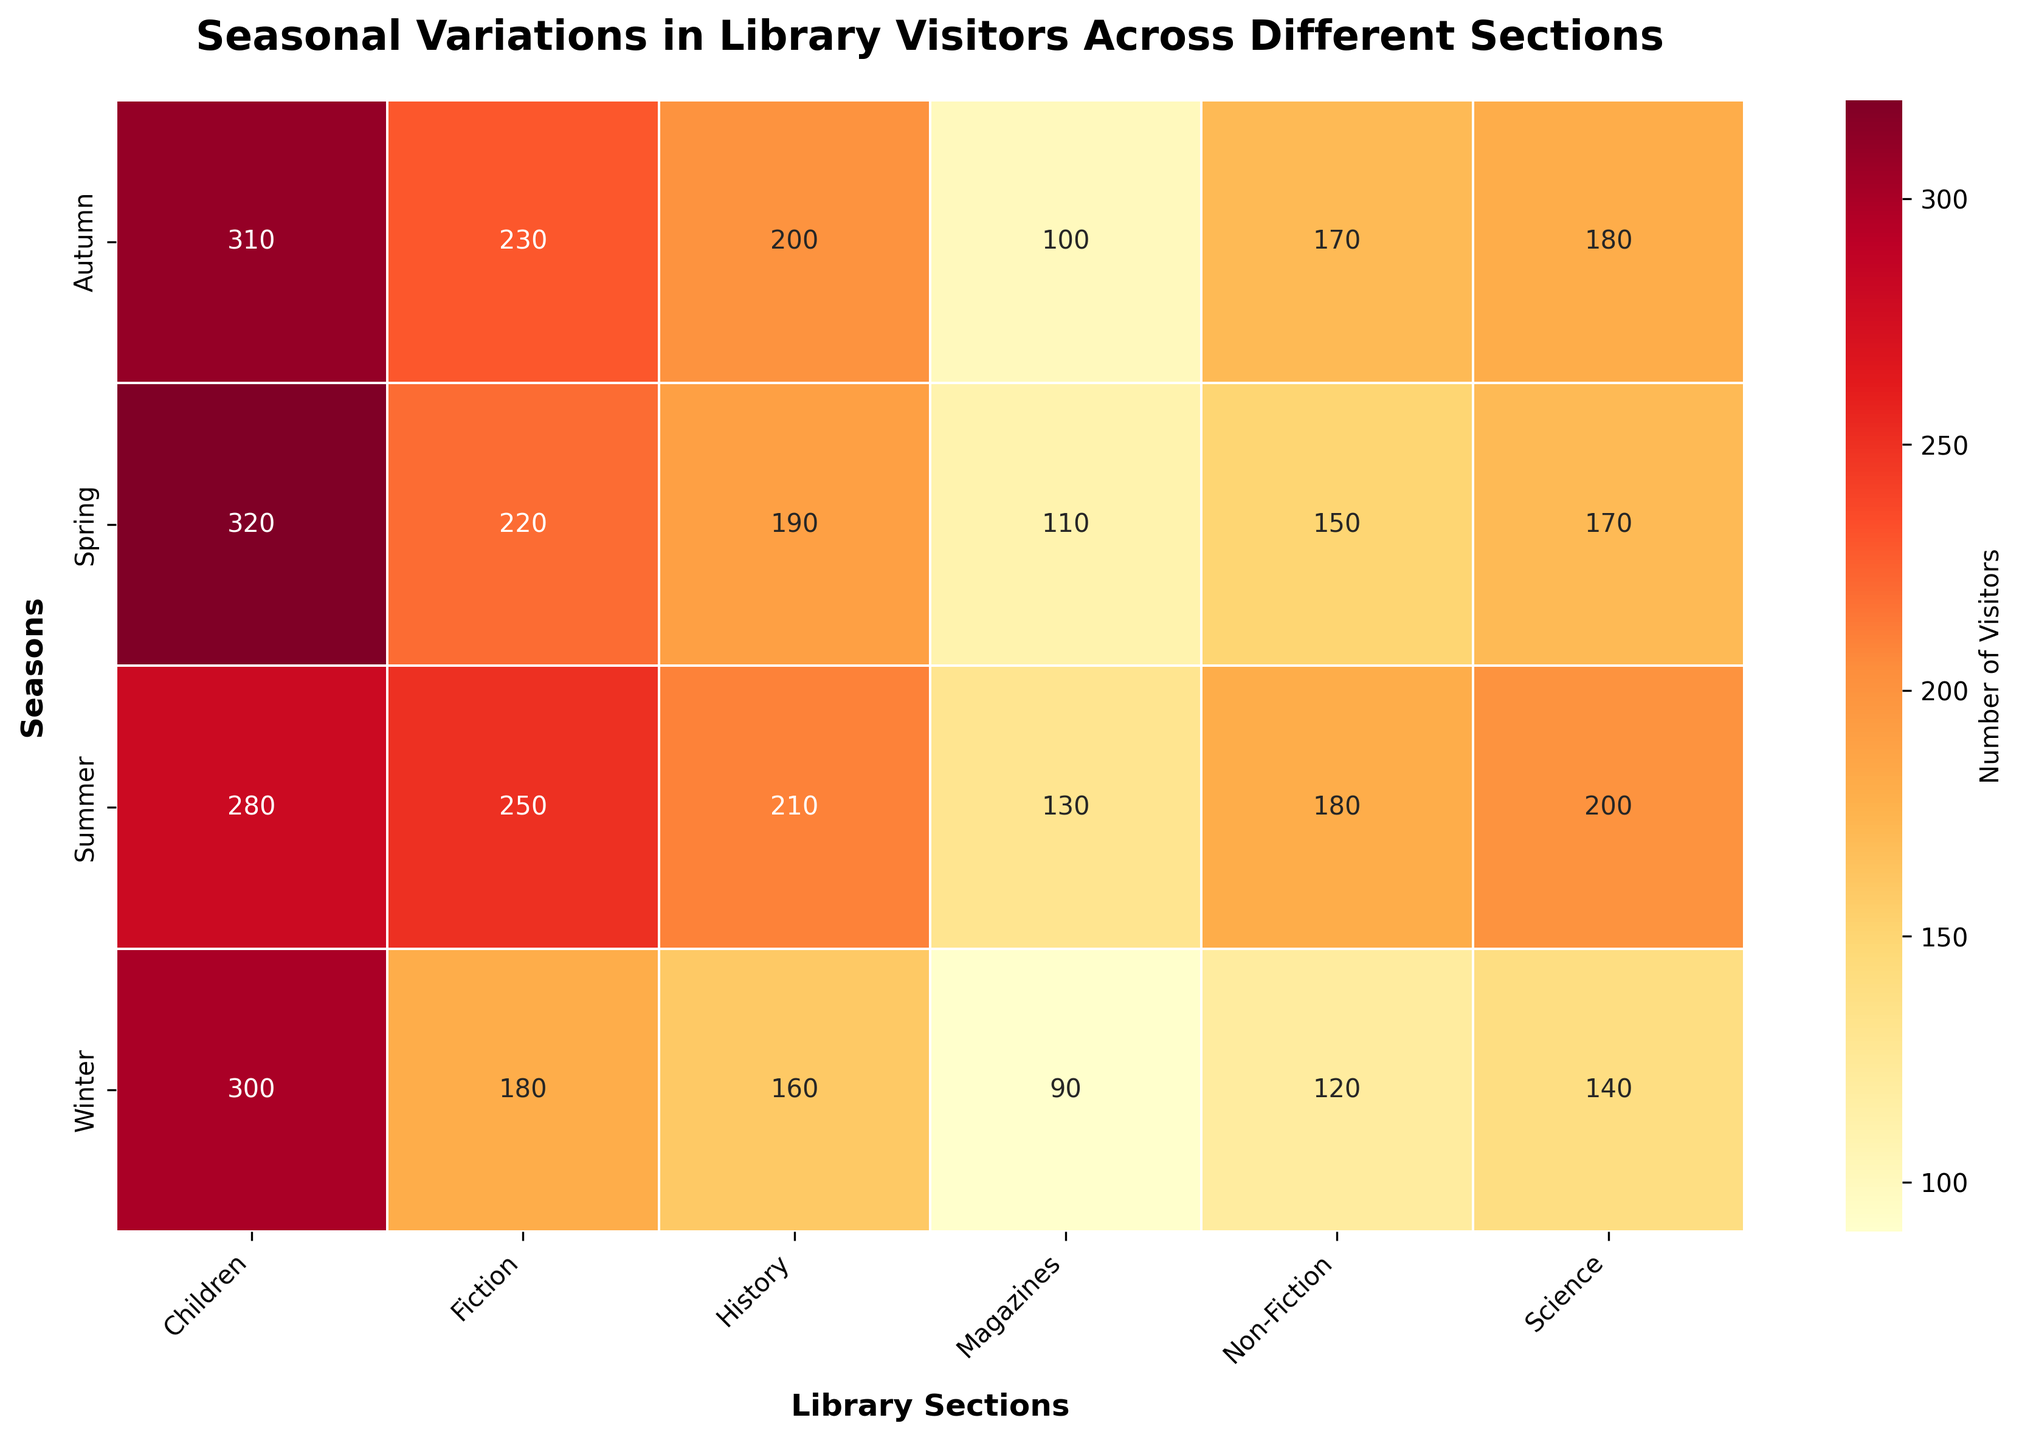What is the title of the heatmap? The title of a heatmap is usually displayed at the top of the figure. It summarizes the contents and purpose of the heatmap.
Answer: Seasonal Variations in Library Visitors Across Different Sections Which season has the highest number of visitors in the Children's section? To find the season with the highest number of visitors in a particular section, locate the column for the Children's section and identify the highest value within that column.
Answer: Spring Which section had the lowest number of visitors in Summer? To determine this, look at the row labeled "Summer" and find the minimum value within that row.
Answer: Magazines What is the total number of visitors in the Fiction section across all seasons? Sum the number of visitors in the Fiction section for each season: 180 (Winter) + 220 (Spring) + 250 (Summer) + 230 (Autumn) = 880
Answer: 880 Compare the number of visitors in the History section between Winter and Autumn. Which season had more visitors and by how much? Locate the number of visitors in the History section for both Winter and Autumn. Subtract the Winter value (160) from the Autumn value (200) to see the difference.
Answer: Autumn had 40 more visitors What is the average number of visitors in the Non-Fiction section across the four seasons? Calculate the average by summing the number of visitors in the Non-Fiction section for each season and dividing by the number of seasons: (120 + 150 + 180 + 170) / 4 = 155
Answer: 155 In which season do the Science and Magazines sections have the same number of visitors? Compare the visitor numbers for Science and Magazines in each season to find where they match.
Answer: No season Among all sections, which one saw a general increase in visitors from Winter to Summer? Examine the visitor numbers for each section from Winter to Summer to see if they increased continuously: Fiction (180 to 250), Non-Fiction (120 to 180), Children (300 to 280), Science (140 to 200), History (160 to 210), Magazines (90 to 130). Multiple sections increased, Fiction, Non-Fiction, Science, History, and Magazines all increased.
Answer: Fiction, Non-Fiction, Science, History, Magazines Which section experienced the smallest variation in visitor numbers throughout the year? To determine the smallest variation, calculate the range (max-min) for each section and identify the minimum one: Fiction (250-180=70), Non-Fiction (180-120=60), Children (320-280=40), Science (200-140=60), History (210-160=50), Magazines (130-90=40). The smallest variation is 40, observed in Children and Magazines.
Answer: Children, Magazines 